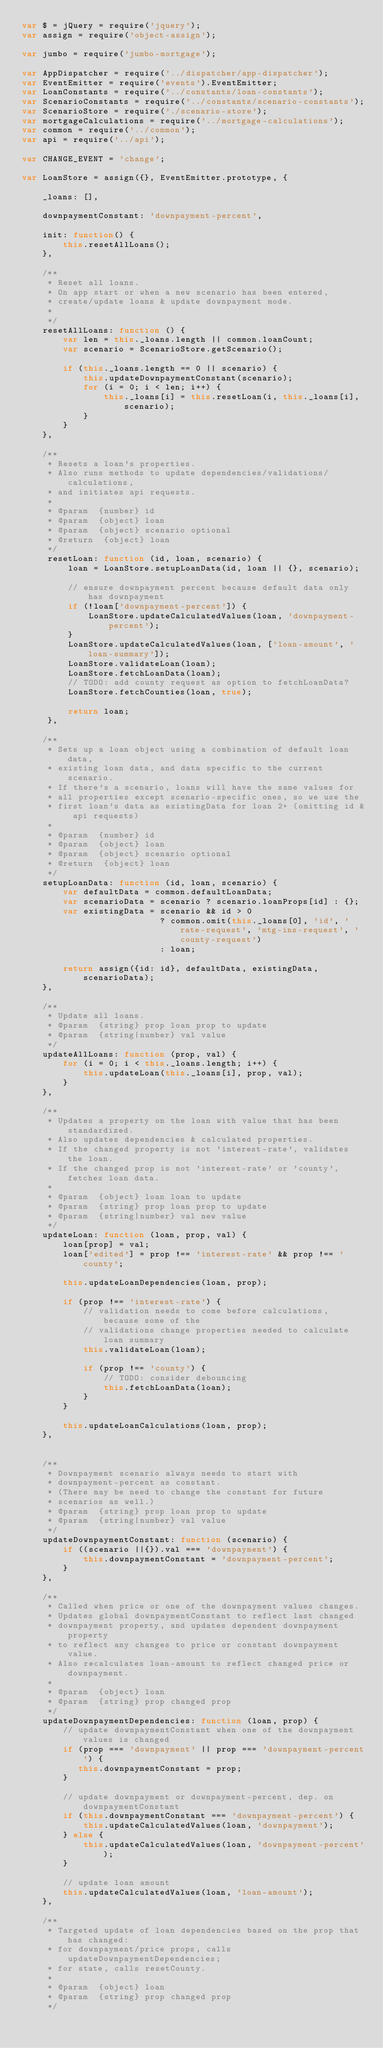Convert code to text. <code><loc_0><loc_0><loc_500><loc_500><_JavaScript_>var $ = jQuery = require('jquery');
var assign = require('object-assign');

var jumbo = require('jumbo-mortgage');

var AppDispatcher = require('../dispatcher/app-dispatcher');
var EventEmitter = require('events').EventEmitter;
var LoanConstants = require('../constants/loan-constants');
var ScenarioConstants = require('../constants/scenario-constants');
var ScenarioStore = require('./scenario-store');
var mortgageCalculations = require('../mortgage-calculations');
var common = require('../common');
var api = require('../api');

var CHANGE_EVENT = 'change';

var LoanStore = assign({}, EventEmitter.prototype, {
    
    _loans: [],
    
    downpaymentConstant: 'downpayment-percent',
    
    init: function() {
        this.resetAllLoans();
    },
    
    /**
     * Reset all loans.
     * On app start or when a new scenario has been entered,
     * create/update loans & update downpayment mode.
     *
     */
    resetAllLoans: function () {
        var len = this._loans.length || common.loanCount;
        var scenario = ScenarioStore.getScenario();
              
        if (this._loans.length == 0 || scenario) {
            this.updateDownpaymentConstant(scenario);
            for (i = 0; i < len; i++) {
                this._loans[i] = this.resetLoan(i, this._loans[i], scenario);
            }
        }    
    },
    
    /**
     * Resets a loan's properties.
     * Also runs methods to update dependencies/validations/calculations,
     * and initiates api requests.
     *
     * @param  {number} id 
     * @param  {object} loan 
     * @param  {object} scenario optional
     * @return  {object} loan
     */
     resetLoan: function (id, loan, scenario) {
         loan = LoanStore.setupLoanData(id, loan || {}, scenario);
         
         // ensure downpayment percent because default data only has downpayment
         if (!loan['downpayment-percent']) {
             LoanStore.updateCalculatedValues(loan, 'downpayment-percent');
         }
         LoanStore.updateCalculatedValues(loan, ['loan-amount', 'loan-summary']);
         LoanStore.validateLoan(loan);
         LoanStore.fetchLoanData(loan);
         // TODO: add county request as option to fetchLoanData?
         LoanStore.fetchCounties(loan, true);
         
         return loan;
     },
    
    /**
     * Sets up a loan object using a combination of default loan data,
     * existing loan data, and data specific to the current scenario.
     * If there's a scenario, loans will have the same values for 
     * all properties except scenario-specific ones, so we use the 
     * first loan's data as existingData for loan 2+ (omitting id & api requests)
     *
     * @param  {number} id 
     * @param  {object} loan 
     * @param  {object} scenario optional
     * @return  {object} loan
     */
    setupLoanData: function (id, loan, scenario) {
        var defaultData = common.defaultLoanData;
        var scenarioData = scenario ? scenario.loanProps[id] : {};        
        var existingData = scenario && id > 0 
                           ? common.omit(this._loans[0], 'id', 'rate-request', 'mtg-ins-request', 'county-request')
                           : loan;
        
        return assign({id: id}, defaultData, existingData, scenarioData);
    },
    
    /**
     * Update all loans.
     * @param  {string} prop loan prop to update
     * @param  {string|number} val value
     */
    updateAllLoans: function (prop, val) {
        for (i = 0; i < this._loans.length; i++) {
            this.updateLoan(this._loans[i], prop, val);
        }
    },
    
    /**
     * Updates a property on the loan with value that has been standardized.
     * Also updates dependencies & calculated properties.
     * If the changed property is not 'interest-rate', validates the loan.
     * If the changed prop is not 'interest-rate' or 'county', fetches loan data.
     *
     * @param  {object} loan loan to update
     * @param  {string} prop loan prop to update
     * @param  {string|number} val new value
     */
    updateLoan: function (loan, prop, val) {           
        loan[prop] = val;
        loan['edited'] = prop !== 'interest-rate' && prop !== 'county';
        
        this.updateLoanDependencies(loan, prop);

        if (prop !== 'interest-rate') {
            // validation needs to come before calculations, because some of the 
            // validations change properties needed to calculate loan summary
            this.validateLoan(loan);
            
            if (prop !== 'county') {
                // TODO: consider debouncing
                this.fetchLoanData(loan);
            }
        }
                
        this.updateLoanCalculations(loan, prop);        
    },
    
    
    /**
     * Downpayment scenario always needs to start with
     * downpayment-percent as constant.
     * (There may be need to change the constant for future
     * scenarios as well.)
     * @param  {string} prop loan prop to update
     * @param  {string|number} val value
     */
    updateDownpaymentConstant: function (scenario) {
        if ((scenario ||{}).val === 'downpayment') {
            this.downpaymentConstant = 'downpayment-percent';
        }
    },
    
    /**
     * Called when price or one of the downpayment values changes.
     * Updates global downpaymentConstant to reflect last changed
     * downpayment property, and updates dependent downpayment property
     * to reflect any changes to price or constant downpayment value.
     * Also recalculates loan-amount to reflect changed price or downpayment.
     *
     * @param  {object} loan 
     * @param  {string} prop changed prop
     */
    updateDownpaymentDependencies: function (loan, prop) {
        // update downpaymentConstant when one of the downpayment values is changed
        if (prop === 'downpayment' || prop === 'downpayment-percent') {
           this.downpaymentConstant = prop;
        }
        
        // update downpayment or downpayment-percent, dep. on downpaymentConstant
        if (this.downpaymentConstant === 'downpayment-percent') {
            this.updateCalculatedValues(loan, 'downpayment');
        } else {
            this.updateCalculatedValues(loan, 'downpayment-percent');
        }
        
        // update loan amount
        this.updateCalculatedValues(loan, 'loan-amount');
    }, 
    
    /**
     * Targeted update of loan dependencies based on the prop that has changed: 
     * for downpayment/price props, calls updateDownpaymentDependencies;
     * for state, calls resetCounty.
     *
     * @param  {object} loan 
     * @param  {string} prop changed prop
     */</code> 